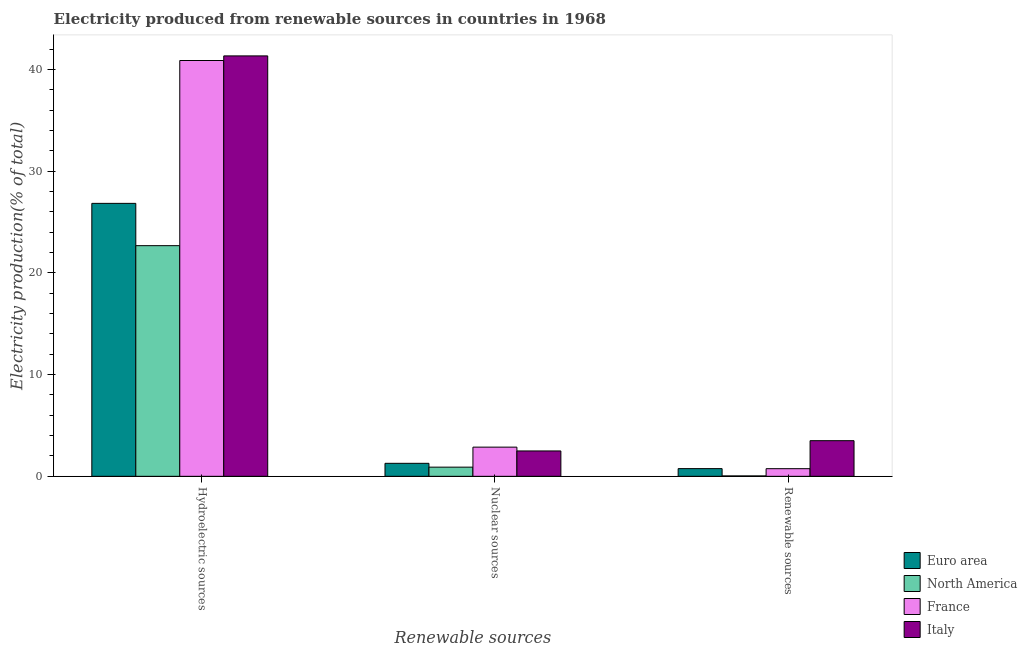How many different coloured bars are there?
Keep it short and to the point. 4. How many groups of bars are there?
Give a very brief answer. 3. Are the number of bars on each tick of the X-axis equal?
Make the answer very short. Yes. How many bars are there on the 2nd tick from the left?
Give a very brief answer. 4. What is the label of the 2nd group of bars from the left?
Ensure brevity in your answer.  Nuclear sources. What is the percentage of electricity produced by hydroelectric sources in Italy?
Your answer should be compact. 41.35. Across all countries, what is the maximum percentage of electricity produced by hydroelectric sources?
Give a very brief answer. 41.35. Across all countries, what is the minimum percentage of electricity produced by hydroelectric sources?
Offer a very short reply. 22.69. What is the total percentage of electricity produced by nuclear sources in the graph?
Provide a short and direct response. 7.55. What is the difference between the percentage of electricity produced by nuclear sources in Italy and that in North America?
Offer a very short reply. 1.59. What is the difference between the percentage of electricity produced by hydroelectric sources in Euro area and the percentage of electricity produced by nuclear sources in North America?
Make the answer very short. 25.94. What is the average percentage of electricity produced by hydroelectric sources per country?
Your answer should be compact. 32.94. What is the difference between the percentage of electricity produced by nuclear sources and percentage of electricity produced by renewable sources in North America?
Provide a succinct answer. 0.86. In how many countries, is the percentage of electricity produced by nuclear sources greater than 14 %?
Keep it short and to the point. 0. What is the ratio of the percentage of electricity produced by hydroelectric sources in Italy to that in North America?
Provide a succinct answer. 1.82. What is the difference between the highest and the second highest percentage of electricity produced by hydroelectric sources?
Offer a very short reply. 0.45. What is the difference between the highest and the lowest percentage of electricity produced by hydroelectric sources?
Keep it short and to the point. 18.66. In how many countries, is the percentage of electricity produced by nuclear sources greater than the average percentage of electricity produced by nuclear sources taken over all countries?
Provide a succinct answer. 2. What does the 2nd bar from the left in Hydroelectric sources represents?
Provide a short and direct response. North America. What does the 2nd bar from the right in Renewable sources represents?
Provide a succinct answer. France. What is the difference between two consecutive major ticks on the Y-axis?
Provide a succinct answer. 10. Are the values on the major ticks of Y-axis written in scientific E-notation?
Your answer should be compact. No. Does the graph contain any zero values?
Your answer should be very brief. No. Where does the legend appear in the graph?
Offer a terse response. Bottom right. How many legend labels are there?
Your response must be concise. 4. How are the legend labels stacked?
Offer a terse response. Vertical. What is the title of the graph?
Your answer should be compact. Electricity produced from renewable sources in countries in 1968. Does "United States" appear as one of the legend labels in the graph?
Your response must be concise. No. What is the label or title of the X-axis?
Ensure brevity in your answer.  Renewable sources. What is the label or title of the Y-axis?
Your answer should be compact. Electricity production(% of total). What is the Electricity production(% of total) of Euro area in Hydroelectric sources?
Make the answer very short. 26.85. What is the Electricity production(% of total) of North America in Hydroelectric sources?
Offer a very short reply. 22.69. What is the Electricity production(% of total) of France in Hydroelectric sources?
Provide a short and direct response. 40.9. What is the Electricity production(% of total) of Italy in Hydroelectric sources?
Your response must be concise. 41.35. What is the Electricity production(% of total) in Euro area in Nuclear sources?
Offer a terse response. 1.28. What is the Electricity production(% of total) in North America in Nuclear sources?
Offer a terse response. 0.9. What is the Electricity production(% of total) in France in Nuclear sources?
Give a very brief answer. 2.87. What is the Electricity production(% of total) of Italy in Nuclear sources?
Offer a terse response. 2.5. What is the Electricity production(% of total) in Euro area in Renewable sources?
Your answer should be very brief. 0.76. What is the Electricity production(% of total) in North America in Renewable sources?
Give a very brief answer. 0.04. What is the Electricity production(% of total) in France in Renewable sources?
Provide a succinct answer. 0.75. What is the Electricity production(% of total) of Italy in Renewable sources?
Offer a terse response. 3.5. Across all Renewable sources, what is the maximum Electricity production(% of total) of Euro area?
Your answer should be very brief. 26.85. Across all Renewable sources, what is the maximum Electricity production(% of total) in North America?
Ensure brevity in your answer.  22.69. Across all Renewable sources, what is the maximum Electricity production(% of total) of France?
Make the answer very short. 40.9. Across all Renewable sources, what is the maximum Electricity production(% of total) in Italy?
Ensure brevity in your answer.  41.35. Across all Renewable sources, what is the minimum Electricity production(% of total) of Euro area?
Keep it short and to the point. 0.76. Across all Renewable sources, what is the minimum Electricity production(% of total) in North America?
Your answer should be very brief. 0.04. Across all Renewable sources, what is the minimum Electricity production(% of total) of France?
Offer a very short reply. 0.75. Across all Renewable sources, what is the minimum Electricity production(% of total) of Italy?
Provide a succinct answer. 2.5. What is the total Electricity production(% of total) in Euro area in the graph?
Your response must be concise. 28.88. What is the total Electricity production(% of total) of North America in the graph?
Ensure brevity in your answer.  23.63. What is the total Electricity production(% of total) in France in the graph?
Offer a very short reply. 44.52. What is the total Electricity production(% of total) of Italy in the graph?
Your answer should be very brief. 47.35. What is the difference between the Electricity production(% of total) in Euro area in Hydroelectric sources and that in Nuclear sources?
Give a very brief answer. 25.57. What is the difference between the Electricity production(% of total) in North America in Hydroelectric sources and that in Nuclear sources?
Offer a very short reply. 21.78. What is the difference between the Electricity production(% of total) of France in Hydroelectric sources and that in Nuclear sources?
Your response must be concise. 38.03. What is the difference between the Electricity production(% of total) in Italy in Hydroelectric sources and that in Nuclear sources?
Your response must be concise. 38.85. What is the difference between the Electricity production(% of total) in Euro area in Hydroelectric sources and that in Renewable sources?
Ensure brevity in your answer.  26.09. What is the difference between the Electricity production(% of total) of North America in Hydroelectric sources and that in Renewable sources?
Offer a very short reply. 22.65. What is the difference between the Electricity production(% of total) in France in Hydroelectric sources and that in Renewable sources?
Offer a terse response. 40.14. What is the difference between the Electricity production(% of total) of Italy in Hydroelectric sources and that in Renewable sources?
Keep it short and to the point. 37.84. What is the difference between the Electricity production(% of total) in Euro area in Nuclear sources and that in Renewable sources?
Your answer should be compact. 0.52. What is the difference between the Electricity production(% of total) in North America in Nuclear sources and that in Renewable sources?
Keep it short and to the point. 0.86. What is the difference between the Electricity production(% of total) of France in Nuclear sources and that in Renewable sources?
Your response must be concise. 2.12. What is the difference between the Electricity production(% of total) in Italy in Nuclear sources and that in Renewable sources?
Give a very brief answer. -1.01. What is the difference between the Electricity production(% of total) in Euro area in Hydroelectric sources and the Electricity production(% of total) in North America in Nuclear sources?
Give a very brief answer. 25.94. What is the difference between the Electricity production(% of total) in Euro area in Hydroelectric sources and the Electricity production(% of total) in France in Nuclear sources?
Give a very brief answer. 23.97. What is the difference between the Electricity production(% of total) of Euro area in Hydroelectric sources and the Electricity production(% of total) of Italy in Nuclear sources?
Make the answer very short. 24.35. What is the difference between the Electricity production(% of total) of North America in Hydroelectric sources and the Electricity production(% of total) of France in Nuclear sources?
Keep it short and to the point. 19.81. What is the difference between the Electricity production(% of total) in North America in Hydroelectric sources and the Electricity production(% of total) in Italy in Nuclear sources?
Your response must be concise. 20.19. What is the difference between the Electricity production(% of total) in France in Hydroelectric sources and the Electricity production(% of total) in Italy in Nuclear sources?
Make the answer very short. 38.4. What is the difference between the Electricity production(% of total) of Euro area in Hydroelectric sources and the Electricity production(% of total) of North America in Renewable sources?
Offer a terse response. 26.81. What is the difference between the Electricity production(% of total) in Euro area in Hydroelectric sources and the Electricity production(% of total) in France in Renewable sources?
Provide a short and direct response. 26.09. What is the difference between the Electricity production(% of total) of Euro area in Hydroelectric sources and the Electricity production(% of total) of Italy in Renewable sources?
Give a very brief answer. 23.34. What is the difference between the Electricity production(% of total) of North America in Hydroelectric sources and the Electricity production(% of total) of France in Renewable sources?
Offer a very short reply. 21.93. What is the difference between the Electricity production(% of total) in North America in Hydroelectric sources and the Electricity production(% of total) in Italy in Renewable sources?
Provide a succinct answer. 19.18. What is the difference between the Electricity production(% of total) of France in Hydroelectric sources and the Electricity production(% of total) of Italy in Renewable sources?
Make the answer very short. 37.39. What is the difference between the Electricity production(% of total) of Euro area in Nuclear sources and the Electricity production(% of total) of North America in Renewable sources?
Offer a very short reply. 1.24. What is the difference between the Electricity production(% of total) of Euro area in Nuclear sources and the Electricity production(% of total) of France in Renewable sources?
Your answer should be very brief. 0.53. What is the difference between the Electricity production(% of total) in Euro area in Nuclear sources and the Electricity production(% of total) in Italy in Renewable sources?
Give a very brief answer. -2.23. What is the difference between the Electricity production(% of total) of North America in Nuclear sources and the Electricity production(% of total) of France in Renewable sources?
Provide a short and direct response. 0.15. What is the difference between the Electricity production(% of total) of North America in Nuclear sources and the Electricity production(% of total) of Italy in Renewable sources?
Your answer should be compact. -2.6. What is the difference between the Electricity production(% of total) of France in Nuclear sources and the Electricity production(% of total) of Italy in Renewable sources?
Offer a terse response. -0.63. What is the average Electricity production(% of total) of Euro area per Renewable sources?
Keep it short and to the point. 9.63. What is the average Electricity production(% of total) of North America per Renewable sources?
Offer a terse response. 7.88. What is the average Electricity production(% of total) of France per Renewable sources?
Ensure brevity in your answer.  14.84. What is the average Electricity production(% of total) in Italy per Renewable sources?
Your answer should be compact. 15.78. What is the difference between the Electricity production(% of total) in Euro area and Electricity production(% of total) in North America in Hydroelectric sources?
Your answer should be compact. 4.16. What is the difference between the Electricity production(% of total) of Euro area and Electricity production(% of total) of France in Hydroelectric sources?
Offer a very short reply. -14.05. What is the difference between the Electricity production(% of total) in Euro area and Electricity production(% of total) in Italy in Hydroelectric sources?
Provide a short and direct response. -14.5. What is the difference between the Electricity production(% of total) of North America and Electricity production(% of total) of France in Hydroelectric sources?
Offer a very short reply. -18.21. What is the difference between the Electricity production(% of total) in North America and Electricity production(% of total) in Italy in Hydroelectric sources?
Give a very brief answer. -18.66. What is the difference between the Electricity production(% of total) in France and Electricity production(% of total) in Italy in Hydroelectric sources?
Your response must be concise. -0.45. What is the difference between the Electricity production(% of total) in Euro area and Electricity production(% of total) in North America in Nuclear sources?
Your answer should be very brief. 0.38. What is the difference between the Electricity production(% of total) in Euro area and Electricity production(% of total) in France in Nuclear sources?
Your answer should be compact. -1.59. What is the difference between the Electricity production(% of total) of Euro area and Electricity production(% of total) of Italy in Nuclear sources?
Make the answer very short. -1.22. What is the difference between the Electricity production(% of total) of North America and Electricity production(% of total) of France in Nuclear sources?
Provide a succinct answer. -1.97. What is the difference between the Electricity production(% of total) of North America and Electricity production(% of total) of Italy in Nuclear sources?
Offer a very short reply. -1.59. What is the difference between the Electricity production(% of total) of France and Electricity production(% of total) of Italy in Nuclear sources?
Keep it short and to the point. 0.37. What is the difference between the Electricity production(% of total) of Euro area and Electricity production(% of total) of North America in Renewable sources?
Offer a very short reply. 0.72. What is the difference between the Electricity production(% of total) of Euro area and Electricity production(% of total) of France in Renewable sources?
Your answer should be very brief. 0.01. What is the difference between the Electricity production(% of total) of Euro area and Electricity production(% of total) of Italy in Renewable sources?
Offer a very short reply. -2.75. What is the difference between the Electricity production(% of total) in North America and Electricity production(% of total) in France in Renewable sources?
Provide a short and direct response. -0.71. What is the difference between the Electricity production(% of total) of North America and Electricity production(% of total) of Italy in Renewable sources?
Your response must be concise. -3.46. What is the difference between the Electricity production(% of total) of France and Electricity production(% of total) of Italy in Renewable sources?
Offer a terse response. -2.75. What is the ratio of the Electricity production(% of total) in Euro area in Hydroelectric sources to that in Nuclear sources?
Offer a very short reply. 21. What is the ratio of the Electricity production(% of total) of North America in Hydroelectric sources to that in Nuclear sources?
Offer a terse response. 25.16. What is the ratio of the Electricity production(% of total) of France in Hydroelectric sources to that in Nuclear sources?
Offer a very short reply. 14.25. What is the ratio of the Electricity production(% of total) in Italy in Hydroelectric sources to that in Nuclear sources?
Keep it short and to the point. 16.57. What is the ratio of the Electricity production(% of total) of Euro area in Hydroelectric sources to that in Renewable sources?
Offer a very short reply. 35.44. What is the ratio of the Electricity production(% of total) in North America in Hydroelectric sources to that in Renewable sources?
Provide a short and direct response. 573. What is the ratio of the Electricity production(% of total) of France in Hydroelectric sources to that in Renewable sources?
Provide a succinct answer. 54.44. What is the ratio of the Electricity production(% of total) in Italy in Hydroelectric sources to that in Renewable sources?
Provide a short and direct response. 11.8. What is the ratio of the Electricity production(% of total) in Euro area in Nuclear sources to that in Renewable sources?
Your answer should be very brief. 1.69. What is the ratio of the Electricity production(% of total) in North America in Nuclear sources to that in Renewable sources?
Offer a terse response. 22.77. What is the ratio of the Electricity production(% of total) of France in Nuclear sources to that in Renewable sources?
Provide a short and direct response. 3.82. What is the ratio of the Electricity production(% of total) of Italy in Nuclear sources to that in Renewable sources?
Your answer should be compact. 0.71. What is the difference between the highest and the second highest Electricity production(% of total) in Euro area?
Your answer should be compact. 25.57. What is the difference between the highest and the second highest Electricity production(% of total) in North America?
Your answer should be compact. 21.78. What is the difference between the highest and the second highest Electricity production(% of total) of France?
Offer a terse response. 38.03. What is the difference between the highest and the second highest Electricity production(% of total) of Italy?
Offer a very short reply. 37.84. What is the difference between the highest and the lowest Electricity production(% of total) in Euro area?
Keep it short and to the point. 26.09. What is the difference between the highest and the lowest Electricity production(% of total) of North America?
Provide a short and direct response. 22.65. What is the difference between the highest and the lowest Electricity production(% of total) of France?
Your response must be concise. 40.14. What is the difference between the highest and the lowest Electricity production(% of total) of Italy?
Offer a terse response. 38.85. 